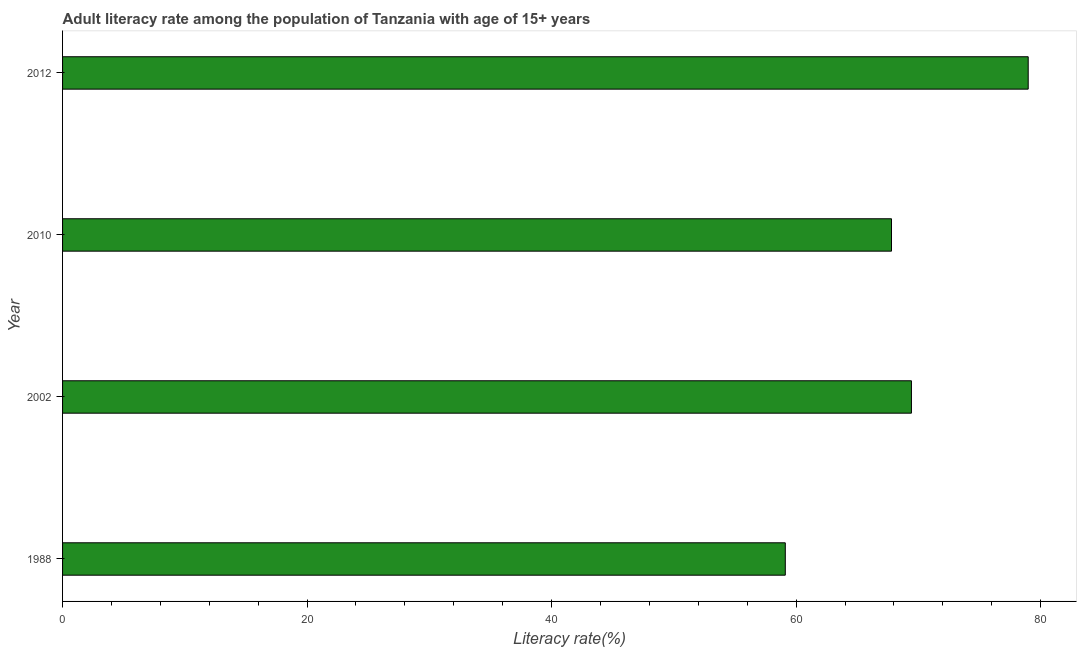Does the graph contain any zero values?
Your response must be concise. No. What is the title of the graph?
Ensure brevity in your answer.  Adult literacy rate among the population of Tanzania with age of 15+ years. What is the label or title of the X-axis?
Offer a very short reply. Literacy rate(%). What is the label or title of the Y-axis?
Ensure brevity in your answer.  Year. What is the adult literacy rate in 2012?
Your answer should be very brief. 78.98. Across all years, what is the maximum adult literacy rate?
Your answer should be compact. 78.98. Across all years, what is the minimum adult literacy rate?
Your answer should be very brief. 59.11. In which year was the adult literacy rate minimum?
Offer a terse response. 1988. What is the sum of the adult literacy rate?
Your answer should be compact. 275.33. What is the difference between the adult literacy rate in 1988 and 2002?
Your answer should be compact. -10.32. What is the average adult literacy rate per year?
Offer a very short reply. 68.83. What is the median adult literacy rate?
Ensure brevity in your answer.  68.62. In how many years, is the adult literacy rate greater than 12 %?
Ensure brevity in your answer.  4. What is the ratio of the adult literacy rate in 1988 to that in 2010?
Make the answer very short. 0.87. What is the difference between the highest and the second highest adult literacy rate?
Ensure brevity in your answer.  9.55. Is the sum of the adult literacy rate in 1988 and 2012 greater than the maximum adult literacy rate across all years?
Keep it short and to the point. Yes. What is the difference between the highest and the lowest adult literacy rate?
Keep it short and to the point. 19.87. How many bars are there?
Your response must be concise. 4. What is the difference between two consecutive major ticks on the X-axis?
Your response must be concise. 20. Are the values on the major ticks of X-axis written in scientific E-notation?
Offer a very short reply. No. What is the Literacy rate(%) of 1988?
Offer a very short reply. 59.11. What is the Literacy rate(%) of 2002?
Your answer should be compact. 69.43. What is the Literacy rate(%) of 2010?
Ensure brevity in your answer.  67.8. What is the Literacy rate(%) of 2012?
Your answer should be very brief. 78.98. What is the difference between the Literacy rate(%) in 1988 and 2002?
Ensure brevity in your answer.  -10.32. What is the difference between the Literacy rate(%) in 1988 and 2010?
Your answer should be compact. -8.69. What is the difference between the Literacy rate(%) in 1988 and 2012?
Keep it short and to the point. -19.87. What is the difference between the Literacy rate(%) in 2002 and 2010?
Give a very brief answer. 1.63. What is the difference between the Literacy rate(%) in 2002 and 2012?
Offer a terse response. -9.55. What is the difference between the Literacy rate(%) in 2010 and 2012?
Your answer should be very brief. -11.18. What is the ratio of the Literacy rate(%) in 1988 to that in 2002?
Ensure brevity in your answer.  0.85. What is the ratio of the Literacy rate(%) in 1988 to that in 2010?
Provide a short and direct response. 0.87. What is the ratio of the Literacy rate(%) in 1988 to that in 2012?
Offer a very short reply. 0.75. What is the ratio of the Literacy rate(%) in 2002 to that in 2010?
Offer a terse response. 1.02. What is the ratio of the Literacy rate(%) in 2002 to that in 2012?
Your answer should be very brief. 0.88. What is the ratio of the Literacy rate(%) in 2010 to that in 2012?
Make the answer very short. 0.86. 